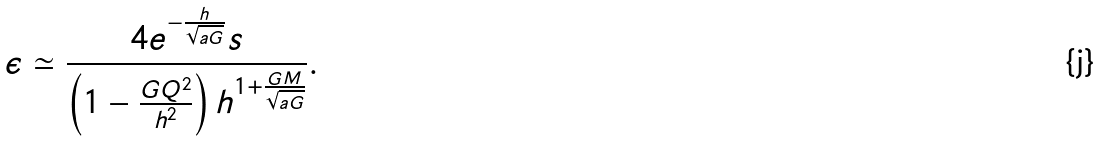<formula> <loc_0><loc_0><loc_500><loc_500>\epsilon \simeq \frac { 4 e ^ { - \frac { h } { \sqrt { a G } } } s } { \left ( 1 - \frac { G Q ^ { 2 } } { h ^ { 2 } } \right ) h ^ { 1 + \frac { G M } { \sqrt { a G } } } } .</formula> 